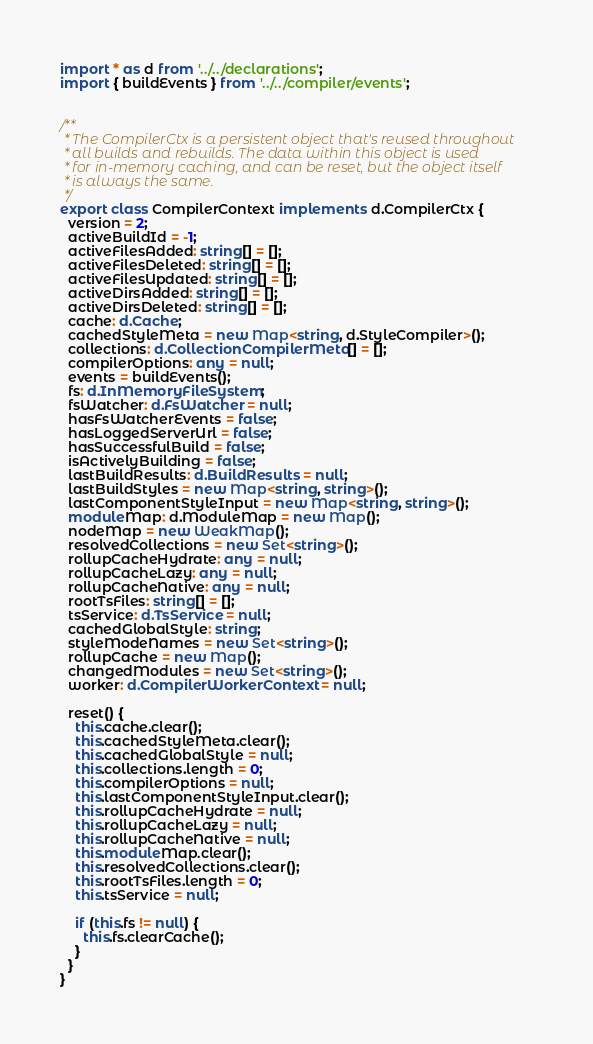Convert code to text. <code><loc_0><loc_0><loc_500><loc_500><_TypeScript_>import * as d from '../../declarations';
import { buildEvents } from '../../compiler/events';


/**
 * The CompilerCtx is a persistent object that's reused throughout
 * all builds and rebuilds. The data within this object is used
 * for in-memory caching, and can be reset, but the object itself
 * is always the same.
 */
export class CompilerContext implements d.CompilerCtx {
  version = 2;
  activeBuildId = -1;
  activeFilesAdded: string[] = [];
  activeFilesDeleted: string[] = [];
  activeFilesUpdated: string[] = [];
  activeDirsAdded: string[] = [];
  activeDirsDeleted: string[] = [];
  cache: d.Cache;
  cachedStyleMeta = new Map<string, d.StyleCompiler>();
  collections: d.CollectionCompilerMeta[] = [];
  compilerOptions: any = null;
  events = buildEvents();
  fs: d.InMemoryFileSystem;
  fsWatcher: d.FsWatcher = null;
  hasFsWatcherEvents = false;
  hasLoggedServerUrl = false;
  hasSuccessfulBuild = false;
  isActivelyBuilding = false;
  lastBuildResults: d.BuildResults = null;
  lastBuildStyles = new Map<string, string>();
  lastComponentStyleInput = new Map<string, string>();
  moduleMap: d.ModuleMap = new Map();
  nodeMap = new WeakMap();
  resolvedCollections = new Set<string>();
  rollupCacheHydrate: any = null;
  rollupCacheLazy: any = null;
  rollupCacheNative: any = null;
  rootTsFiles: string[] = [];
  tsService: d.TsService = null;
  cachedGlobalStyle: string;
  styleModeNames = new Set<string>();
  rollupCache = new Map();
  changedModules = new Set<string>();
  worker: d.CompilerWorkerContext = null;

  reset() {
    this.cache.clear();
    this.cachedStyleMeta.clear();
    this.cachedGlobalStyle = null;
    this.collections.length = 0;
    this.compilerOptions = null;
    this.lastComponentStyleInput.clear();
    this.rollupCacheHydrate = null;
    this.rollupCacheLazy = null;
    this.rollupCacheNative = null;
    this.moduleMap.clear();
    this.resolvedCollections.clear();
    this.rootTsFiles.length = 0;
    this.tsService = null;

    if (this.fs != null) {
      this.fs.clearCache();
    }
  }
}
</code> 